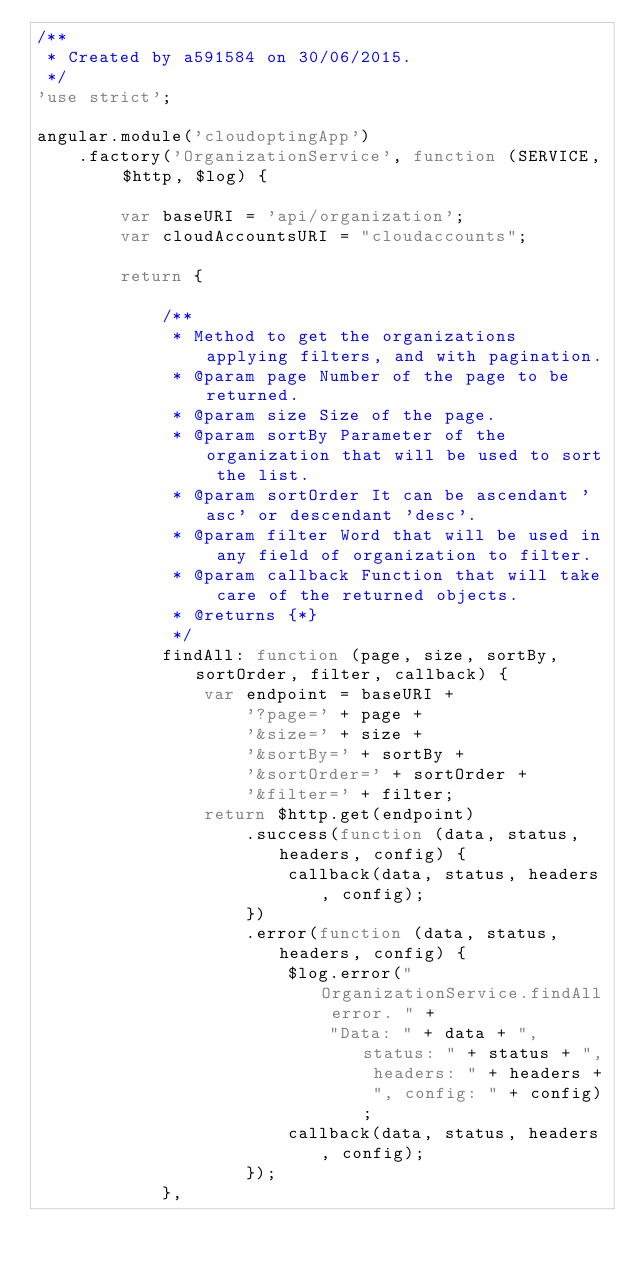Convert code to text. <code><loc_0><loc_0><loc_500><loc_500><_JavaScript_>/**
 * Created by a591584 on 30/06/2015.
 */
'use strict';

angular.module('cloudoptingApp')
    .factory('OrganizationService', function (SERVICE, $http, $log) {

        var baseURI = 'api/organization';
        var cloudAccountsURI = "cloudaccounts";

        return {

            /**
             * Method to get the organizations applying filters, and with pagination.
             * @param page Number of the page to be returned.
             * @param size Size of the page.
             * @param sortBy Parameter of the organization that will be used to sort the list.
             * @param sortOrder It can be ascendant 'asc' or descendant 'desc'.
             * @param filter Word that will be used in any field of organization to filter.
             * @param callback Function that will take care of the returned objects.
             * @returns {*}
             */
            findAll: function (page, size, sortBy, sortOrder, filter, callback) {
                var endpoint = baseURI +
                    '?page=' + page +
                    '&size=' + size +
                    '&sortBy=' + sortBy +
                    '&sortOrder=' + sortOrder +
                    '&filter=' + filter;
                return $http.get(endpoint)
                    .success(function (data, status, headers, config) {
                        callback(data, status, headers, config);
                    })
                    .error(function (data, status, headers, config) {
                        $log.error("OrganizationService.findAll error. " +
                            "Data: " + data + ", status: " + status + ", headers: " + headers + ", config: " + config);
                        callback(data, status, headers, config);
                    });
            },
</code> 